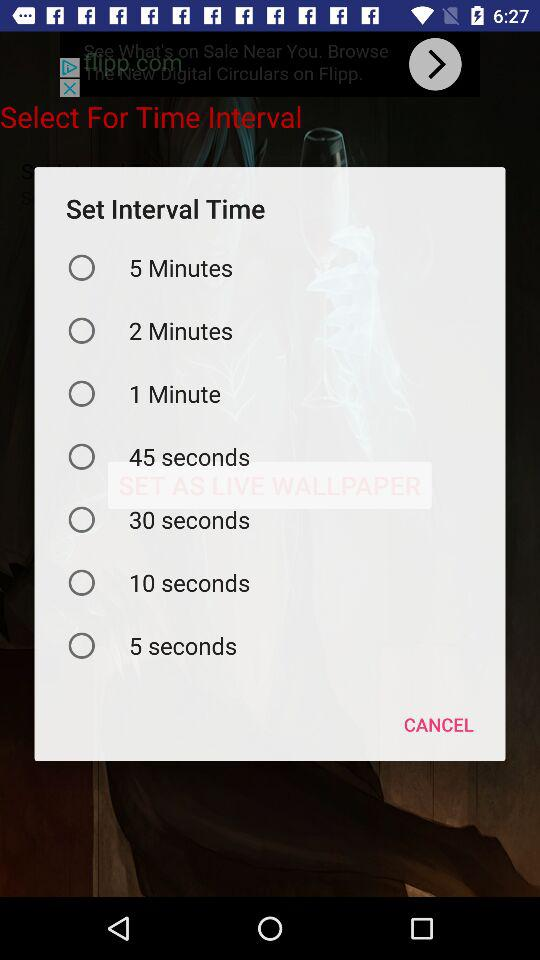How many seconds are there in the shortest interval?
Answer the question using a single word or phrase. 5 